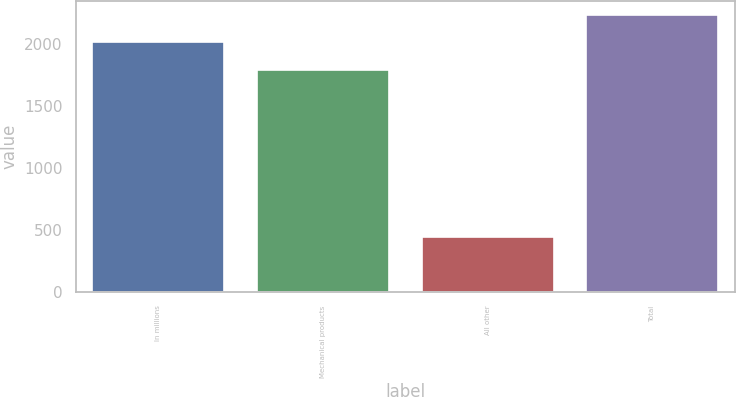Convert chart. <chart><loc_0><loc_0><loc_500><loc_500><bar_chart><fcel>In millions<fcel>Mechanical products<fcel>All other<fcel>Total<nl><fcel>2016<fcel>1793.1<fcel>444.9<fcel>2238<nl></chart> 